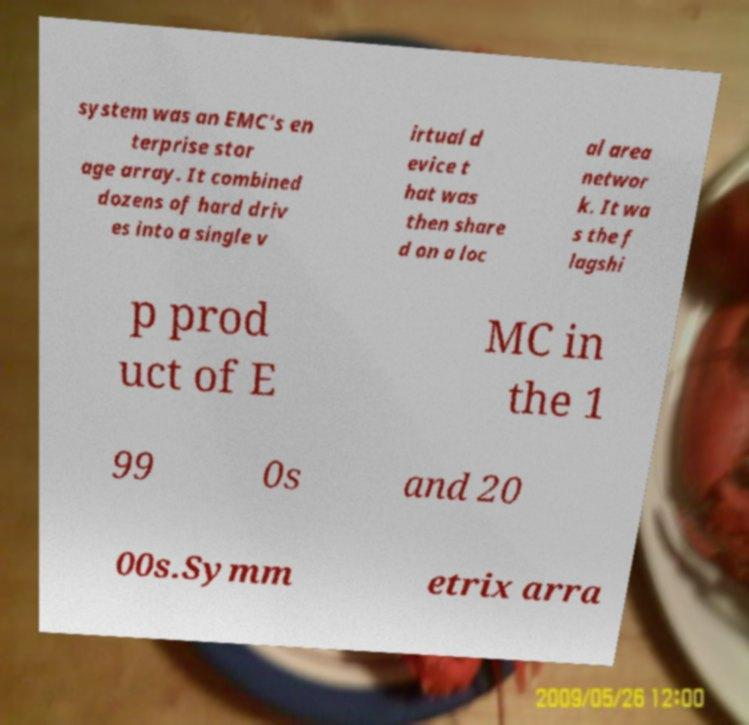I need the written content from this picture converted into text. Can you do that? system was an EMC's en terprise stor age array. It combined dozens of hard driv es into a single v irtual d evice t hat was then share d on a loc al area networ k. It wa s the f lagshi p prod uct of E MC in the 1 99 0s and 20 00s.Symm etrix arra 